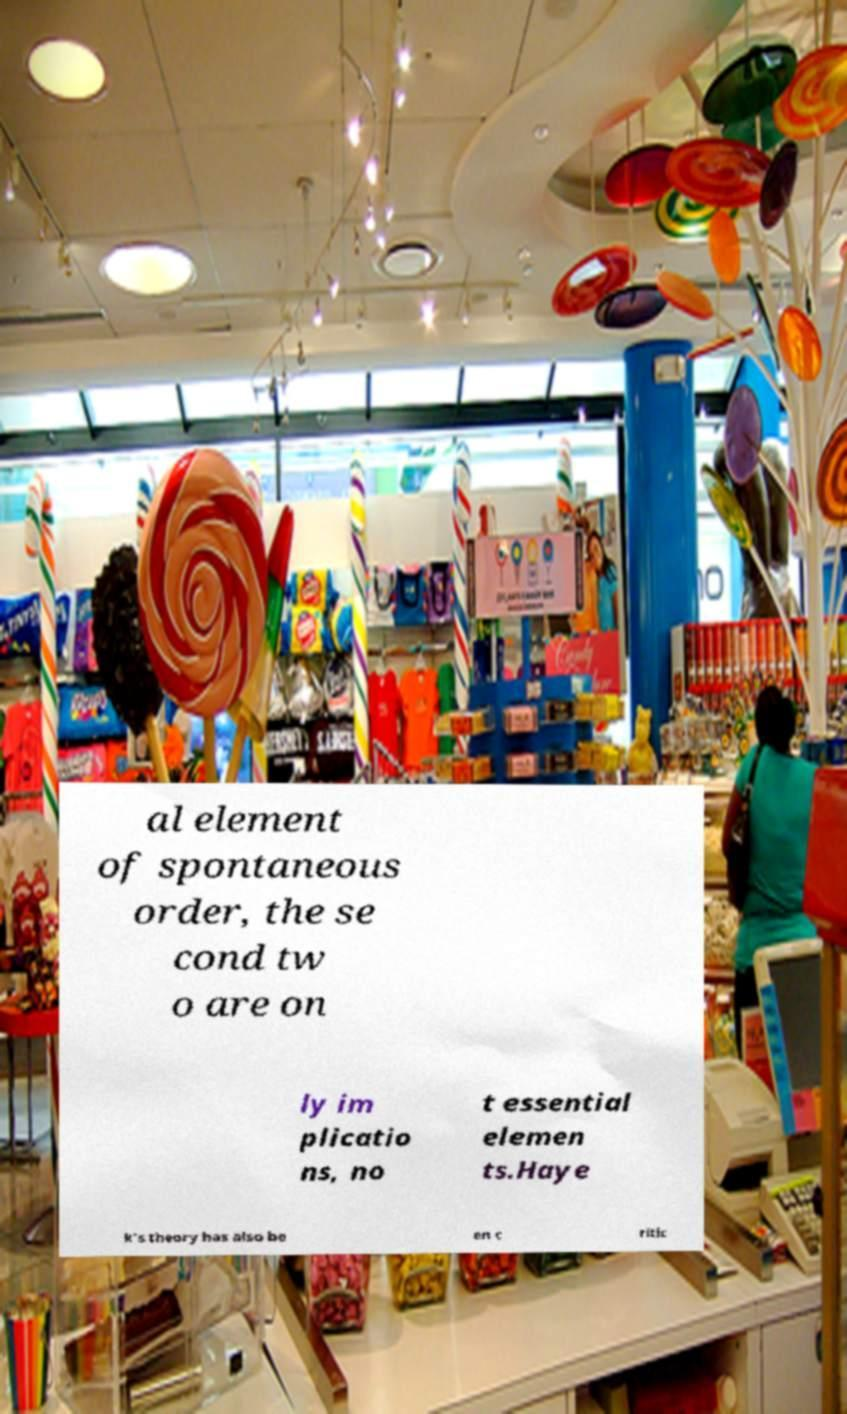For documentation purposes, I need the text within this image transcribed. Could you provide that? al element of spontaneous order, the se cond tw o are on ly im plicatio ns, no t essential elemen ts.Haye k's theory has also be en c ritic 